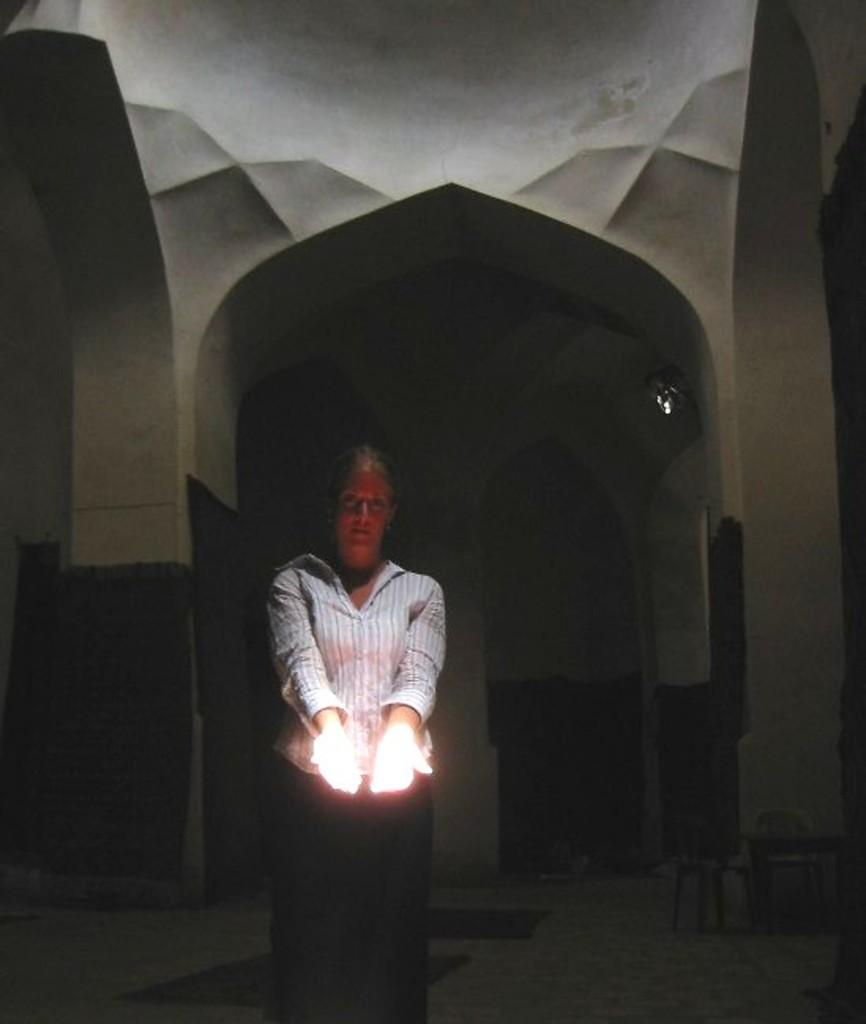Who or what is present in the image? There is a person in the image. What architectural feature can be seen in the image? There are arches in the image. What is on top of the roof in the image? There is an object on the roof in the image. What is the surface beneath the person and arches? There is ground visible in the image. What can be found on the ground in the image? There are objects on the ground in the image. What type of dress is the person wearing in the image? There is no information about the person's clothing in the image, so we cannot determine if they are wearing a dress or not. 